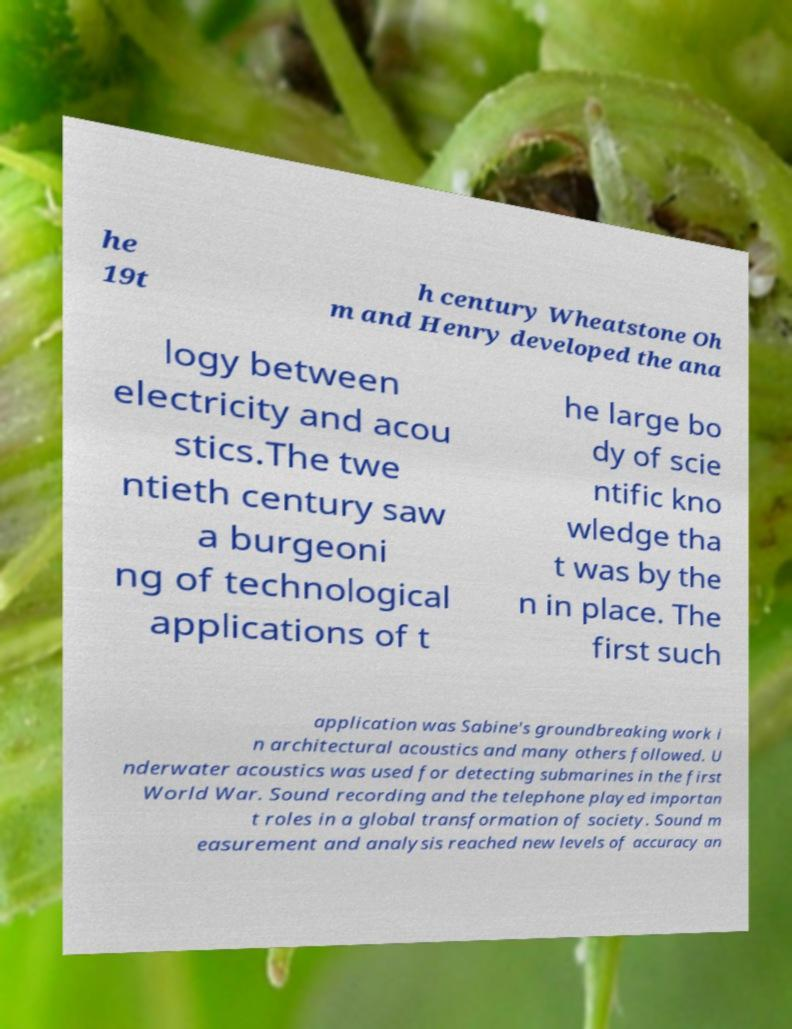I need the written content from this picture converted into text. Can you do that? he 19t h century Wheatstone Oh m and Henry developed the ana logy between electricity and acou stics.The twe ntieth century saw a burgeoni ng of technological applications of t he large bo dy of scie ntific kno wledge tha t was by the n in place. The first such application was Sabine's groundbreaking work i n architectural acoustics and many others followed. U nderwater acoustics was used for detecting submarines in the first World War. Sound recording and the telephone played importan t roles in a global transformation of society. Sound m easurement and analysis reached new levels of accuracy an 